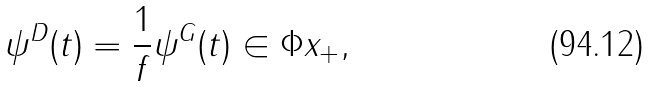<formula> <loc_0><loc_0><loc_500><loc_500>\psi ^ { D } ( t ) = \frac { 1 } { f } \psi ^ { G } ( t ) \in \Phi x _ { + } ,</formula> 